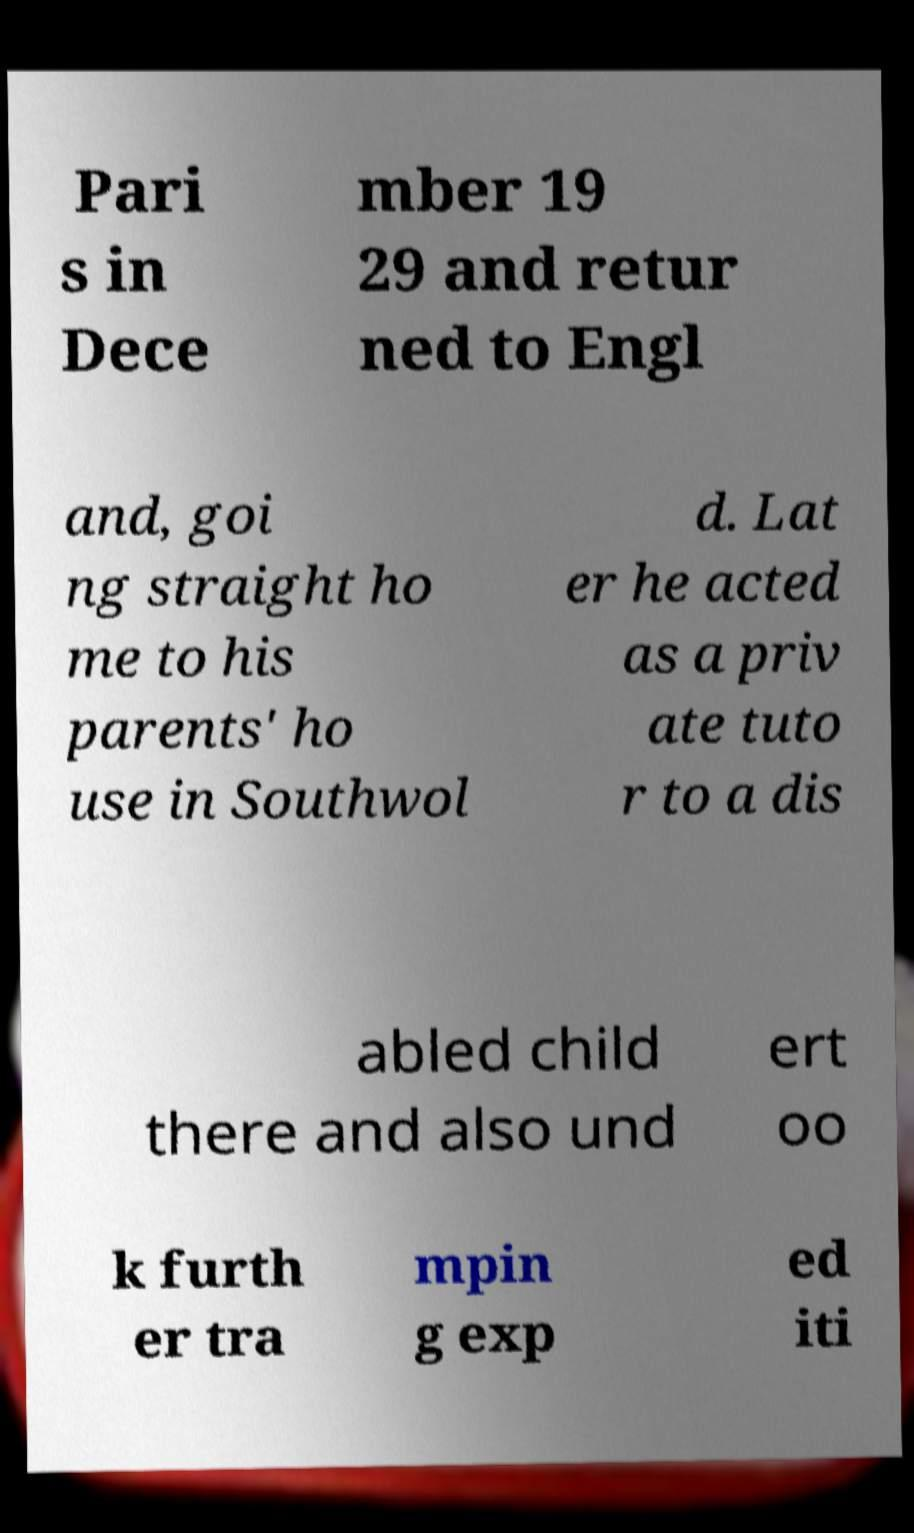Please read and relay the text visible in this image. What does it say? Pari s in Dece mber 19 29 and retur ned to Engl and, goi ng straight ho me to his parents' ho use in Southwol d. Lat er he acted as a priv ate tuto r to a dis abled child there and also und ert oo k furth er tra mpin g exp ed iti 